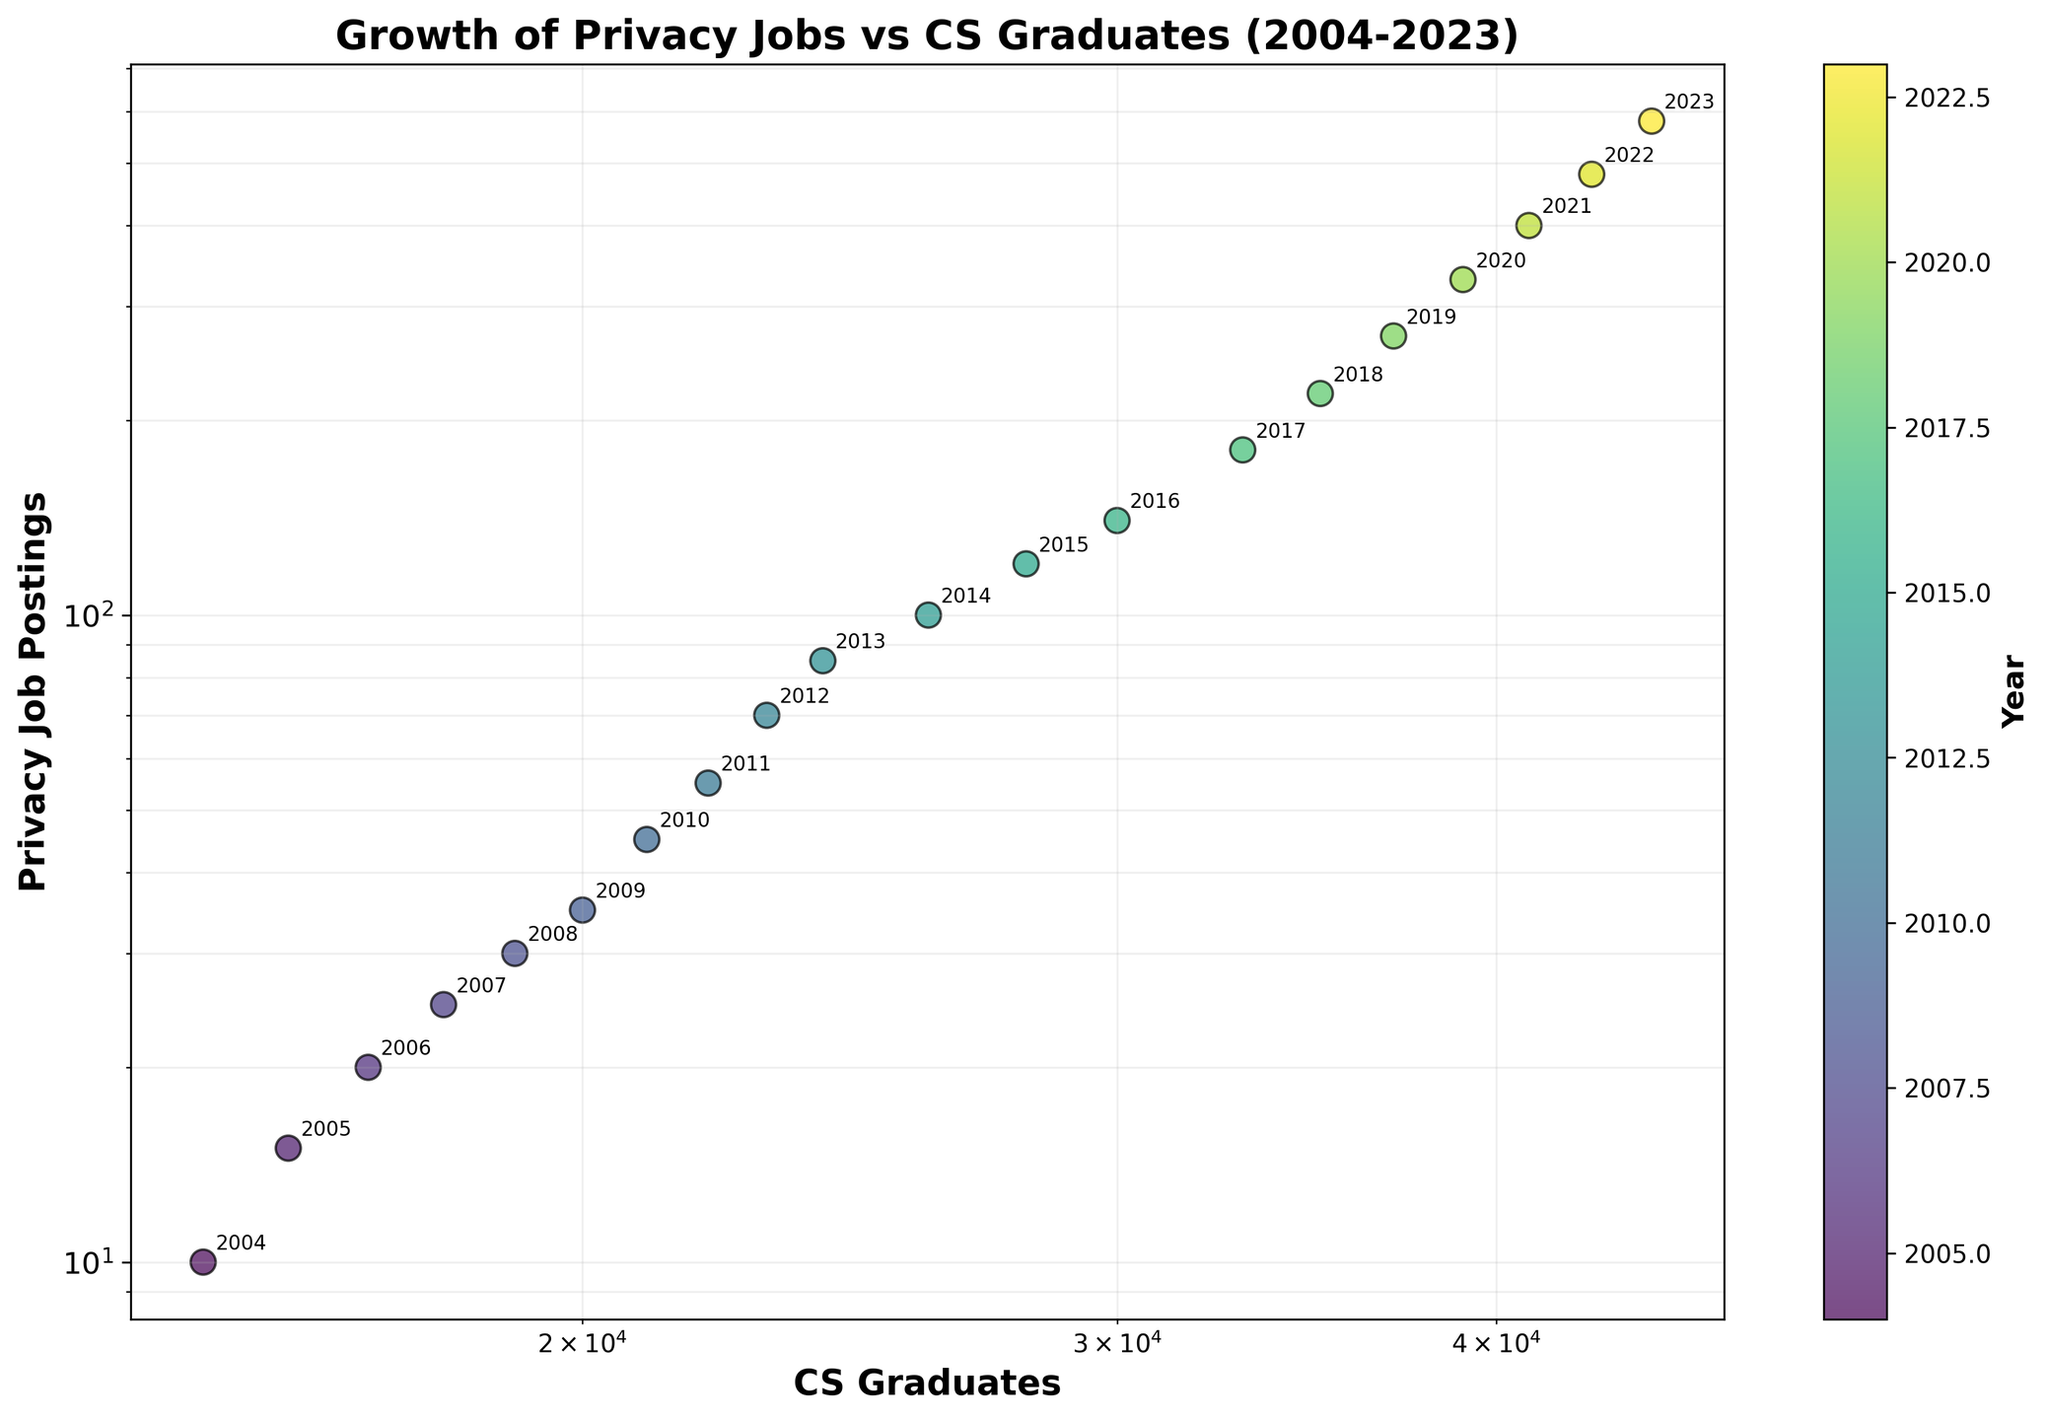What's the title of the figure? The title is usually positioned at the top of the figure. It provides a brief description of what the figure represents.
Answer: Growth of Privacy Jobs vs CS Graduates (2004-2023) How many data points are represented in the scatter plot? To count the data points, refer to the number of marker annotations (years) displayed in the plot.
Answer: 20 What's the label of the x-axis? The x-axis label is found beneath the horizontal axis and describes the data presented along the x-axis.
Answer: CS Graduates What's the label of the y-axis? The y-axis label is found beside the vertical axis and describes the data presented along the y-axis.
Answer: Privacy Job Postings What color represents the year 2023? The color represented in the color bar indicates the spectrum each data point belongs to for the corresponding year. You can find the specific color for 2023 at the end of the spectrum on the right side of the color bar.
Answer: Dark Purple Which year has the lowest number of privacy job postings according to the scatter plot? The year with the lowest privacy job postings is identified as the point with the smallest y-value.
Answer: 2004 What is the x-coordinate for the data point representing the year 2015? The x-coordinate represents the number of CS graduates for the specified year in the scatter plot. For the year 2015, locate the respective annotation on the plot to find its position on the x-axis.
Answer: 28000 What is the trend in privacy job postings over the years? By observing the scatter plot, you can determine the general direction of the data points as they move from left to right, indicating an increasing trend. Privacy job postings generally increase over time.
Answer: Increase How does the growth in privacy job postings compare to the growth in CS graduates over the 20 years? To compare, observe the trend lines and slope changes in the scatter plot for both axes. While both privacy job postings and CS graduates increase, the increase in job postings appears steeper, signifying a higher growth rate.
Answer: Job postings increased more steeply What notable pattern can be observed from the scatter plot with respect to the log scale? On a log scale, evenly spaced steps represent an exponential increase. Notice the clustering of points and their spread. As years advance, points are more widely spread on the plot, indicating rapid exponential growth.
Answer: Exponential growth pattern 